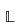<formula> <loc_0><loc_0><loc_500><loc_500>\mathbb { L }</formula> 